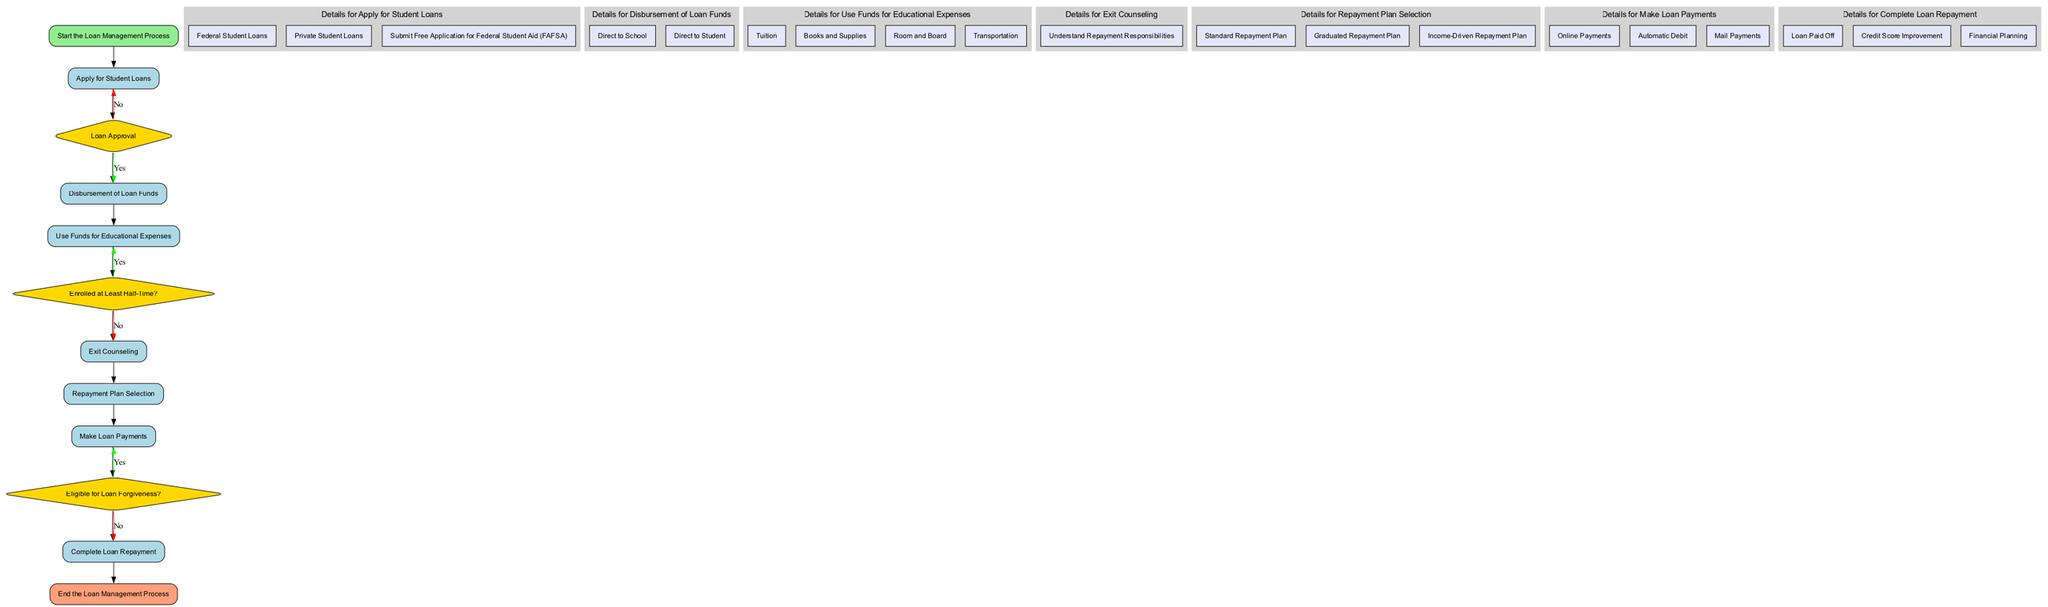What is the first step in the loan management process? The first step is indicated as "Start the Loan Management Process" in the diagram, which is the initial node.
Answer: Start the Loan Management Process How many decision nodes are present in the diagram? By examining the diagram, there are three decision nodes: "Loan Approval", "Enrolled at Least Half-Time?", and "Eligible for Loan Forgiveness?"
Answer: 3 What option is available for applying for student loans? The process node "Apply for Student Loans" lists two options: Federal Student Loans and Private Student Loans. These options indicate the choices available.
Answer: Federal Student Loans, Private Student Loans What happens if a loan is denied? The diagram specifies that if the loan is denied in the "Loan Approval" decision, the flow returns to the "Apply for Student Loans" process for further action.
Answer: Apply for Student Loans If a student is not enrolled at least half-time, what begins next? The flowchart shows that if the student is not enrolled at least half-time, they enter the "Begin Repayment Grace Period". This indicates a transition from enrollment status to repayment preparation.
Answer: Begin Repayment Grace Period What are the payment methods listed for making loan payments? The process node "Make Loan Payments" includes three payment methods: Online Payments, Automatic Debit, and Mail Payments. These are the listed options for payment methods.
Answer: Online Payments, Automatic Debit, Mail Payments What is the outcome of completing loan repayment? According to the node "Complete Loan Repayment", the outcome listed is "Loan Paid Off", which signifies the successful conclusion of the repayment process.
Answer: Loan Paid Off What is the purpose of the exit counseling? The node "Exit Counseling" specifies the goal as understanding repayment responsibilities, which is essential for preparing students for their repayment journey.
Answer: Understand Repayment Responsibilities What are some next steps after completing loan repayment? The process node specifies two next steps following repayment: "Credit Score Improvement" and "Financial Planning", indicating areas for post-repayment focus.
Answer: Credit Score Improvement, Financial Planning 